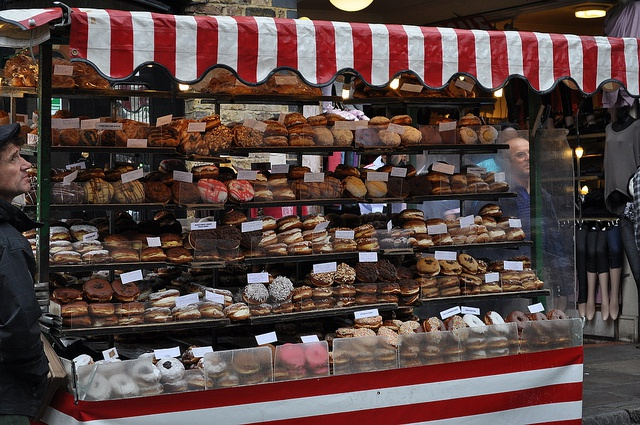Describe the objects in this image and their specific colors. I can see donut in black, maroon, gray, and darkgray tones, people in black, brown, and gray tones, people in black and gray tones, donut in black, brown, and maroon tones, and donut in black, maroon, and brown tones in this image. 